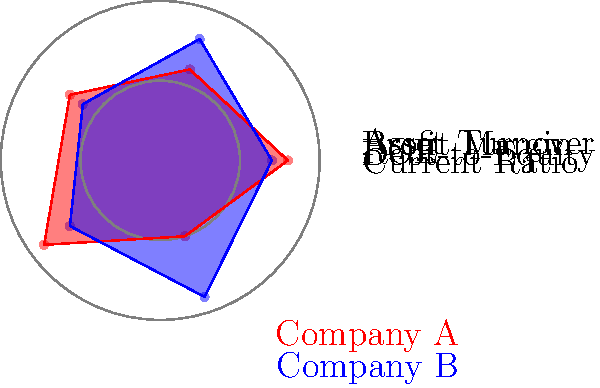Based on the radar chart comparing financial ratios of Company A (red) and Company B (blue), which company appears to have a stronger financial position in terms of liquidity and efficiency? To determine which company has a stronger financial position in terms of liquidity and efficiency, we need to analyze the relevant ratios:

1. Liquidity: Current Ratio
   - Company A: 0.8
   - Company B: 0.7
   Company A has a slightly higher current ratio, indicating better short-term liquidity.

2. Efficiency: Asset Turnover
   - Company A: 0.5
   - Company B: 0.9
   Company B has a significantly higher asset turnover, suggesting better efficiency in using assets to generate sales.

3. Other factors to consider:
   a) Debt-to-Equity:
      - Company A: 0.6
      - Company B: 0.8
      Company A has a lower debt-to-equity ratio, indicating less financial risk.

   b) Return on Equity (ROE):
      - Company A: 0.7
      - Company B: 0.6
      Company A has a slightly higher ROE, suggesting better profitability relative to equity.

   c) Profit Margin:
      - Company A: 0.9
      - Company B: 0.7
      Company A has a higher profit margin, indicating better profitability per dollar of sales.

While Company A shows stronger performance in liquidity (current ratio), profitability (ROE and profit margin), and lower financial risk (debt-to-equity), Company B demonstrates significantly better efficiency in asset utilization (asset turnover).

Considering that the question specifically asks about liquidity and efficiency, we must weigh these two factors more heavily. Company A has a slight edge in liquidity, but Company B has a substantial advantage in efficiency.
Answer: Company B 